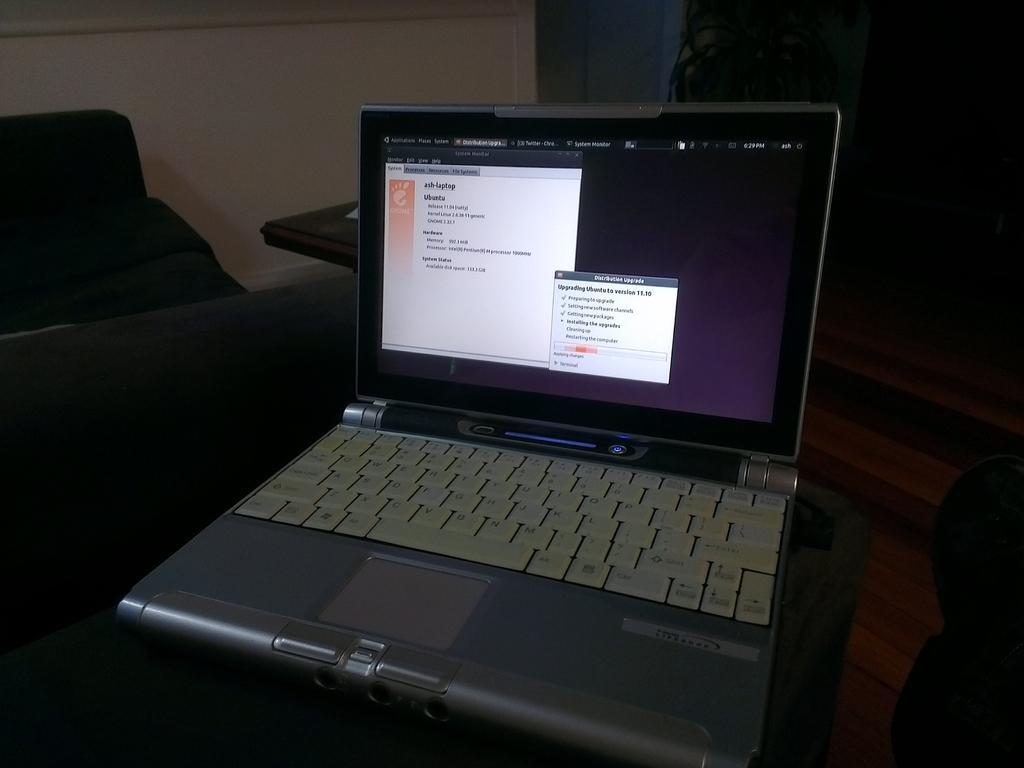In one or two sentences, can you explain what this image depicts? In this picture we can see a laptop in the front, on the left side there is a chair, we can see table in front of it, in the background there is a wall, we can see a plant hire. 